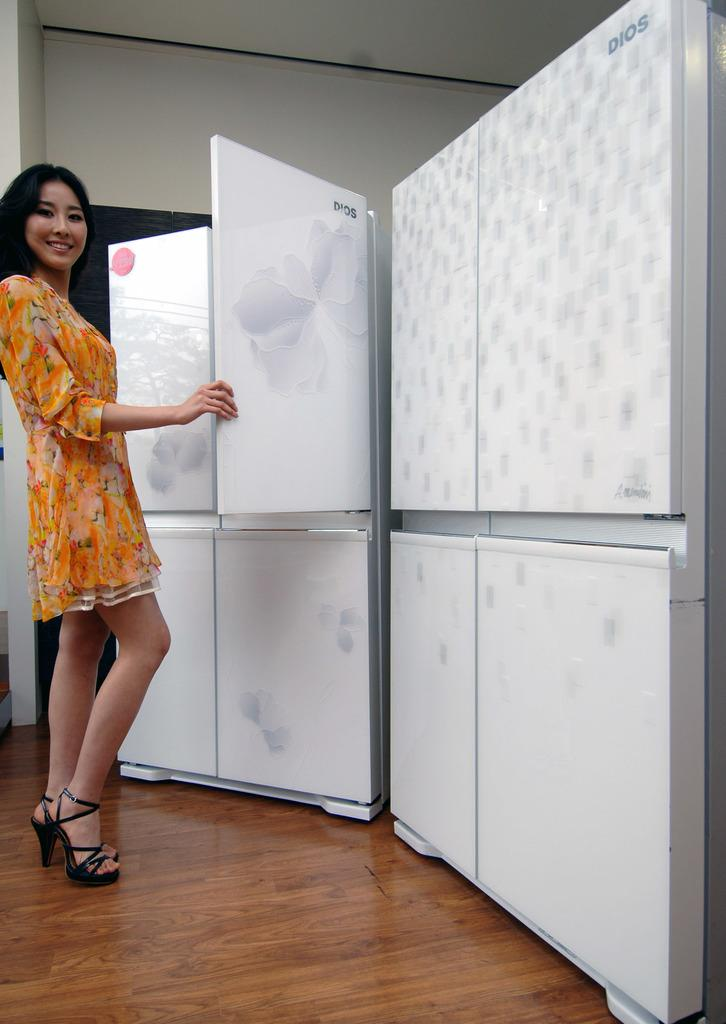<image>
Summarize the visual content of the image. The white Dios refrigerator is being examined by a woman wearing a yellow dress. 